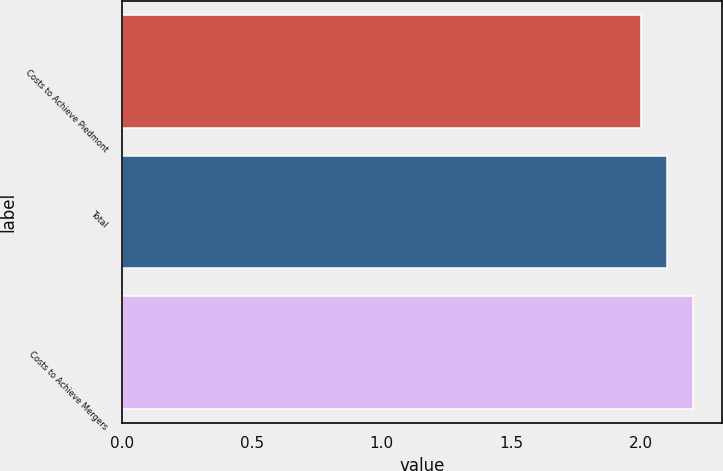Convert chart to OTSL. <chart><loc_0><loc_0><loc_500><loc_500><bar_chart><fcel>Costs to Achieve Piedmont<fcel>Total<fcel>Costs to Achieve Mergers<nl><fcel>2<fcel>2.1<fcel>2.2<nl></chart> 